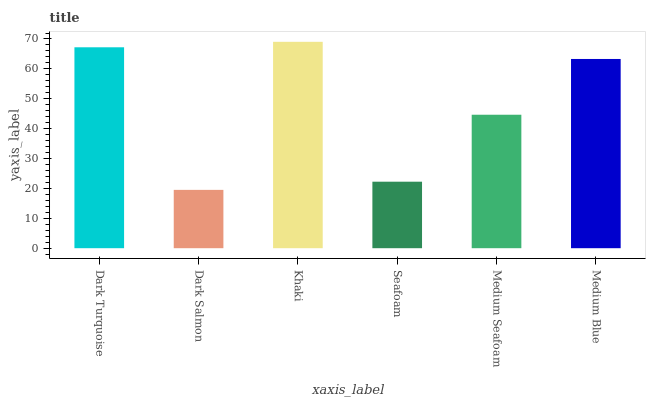Is Dark Salmon the minimum?
Answer yes or no. Yes. Is Khaki the maximum?
Answer yes or no. Yes. Is Khaki the minimum?
Answer yes or no. No. Is Dark Salmon the maximum?
Answer yes or no. No. Is Khaki greater than Dark Salmon?
Answer yes or no. Yes. Is Dark Salmon less than Khaki?
Answer yes or no. Yes. Is Dark Salmon greater than Khaki?
Answer yes or no. No. Is Khaki less than Dark Salmon?
Answer yes or no. No. Is Medium Blue the high median?
Answer yes or no. Yes. Is Medium Seafoam the low median?
Answer yes or no. Yes. Is Dark Salmon the high median?
Answer yes or no. No. Is Dark Turquoise the low median?
Answer yes or no. No. 